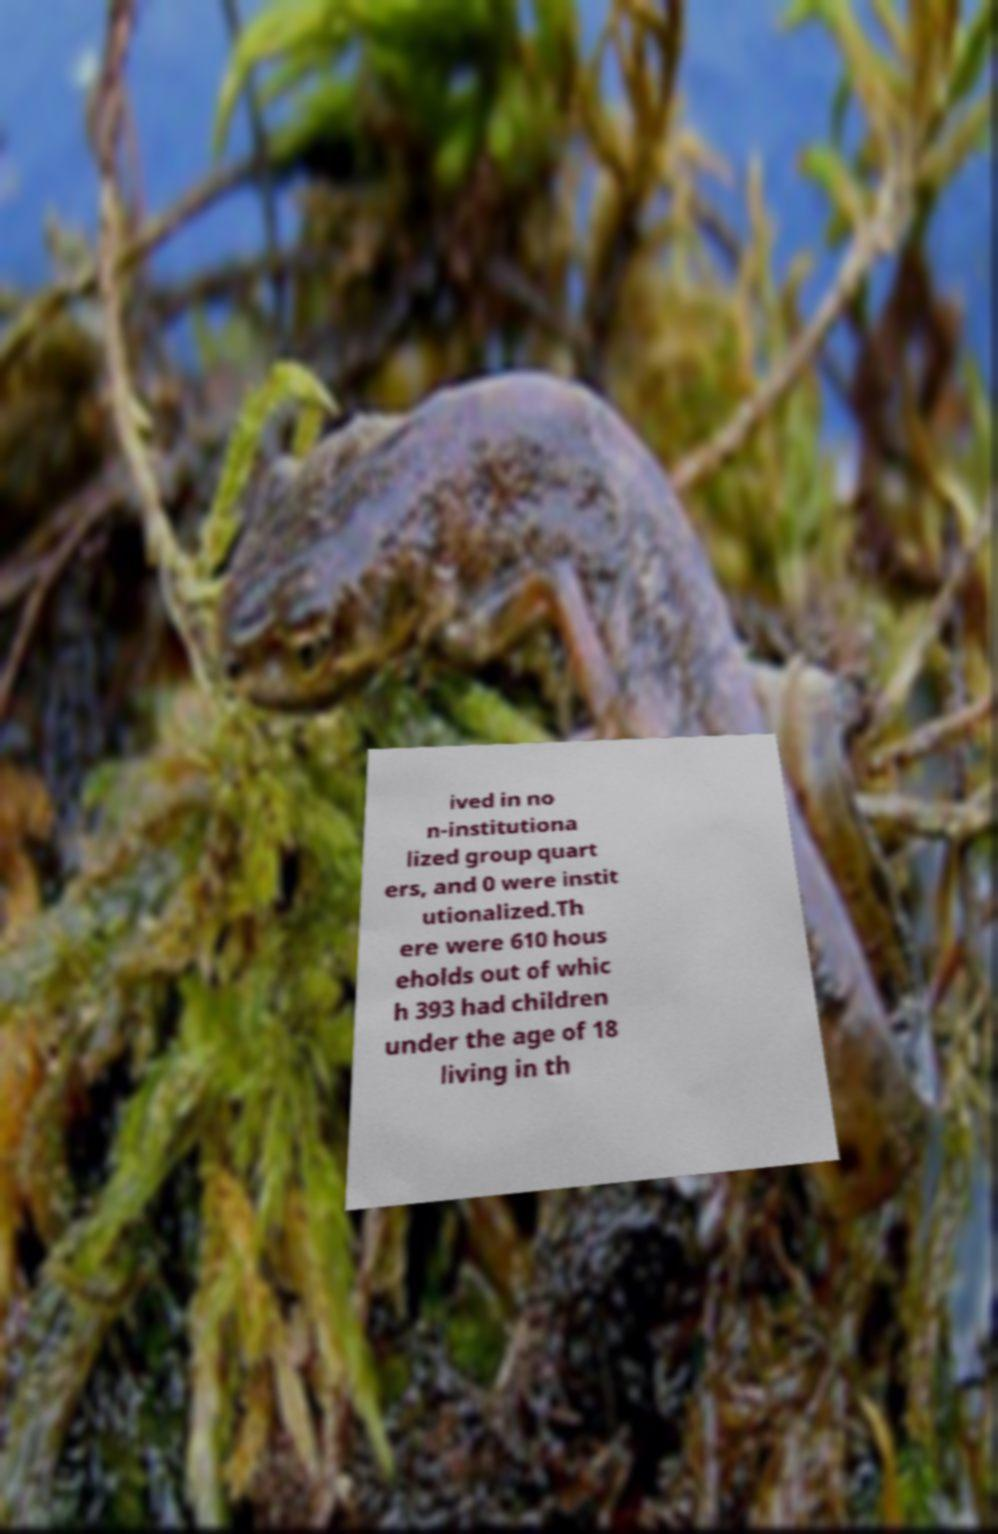Could you extract and type out the text from this image? ived in no n-institutiona lized group quart ers, and 0 were instit utionalized.Th ere were 610 hous eholds out of whic h 393 had children under the age of 18 living in th 